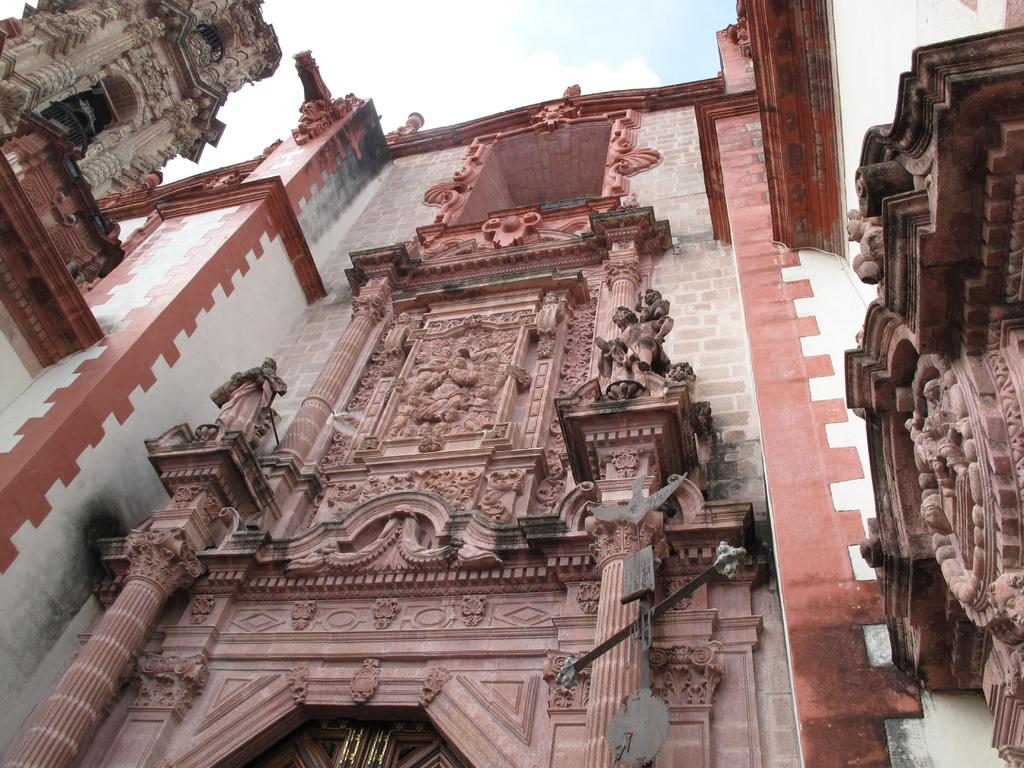What is the main subject of the image? The main subject of the image is a building. Can you describe any specific features of the building? Yes, the building has sculptures on the wall. What is visible at the top of the image? The sky is visible at the top of the image. How many chickens can be seen in the image? There are no chickens present in the image. What is the building pointing towards in the image? The building is not pointing towards anything in the image. 